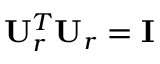<formula> <loc_0><loc_0><loc_500><loc_500>{ U } _ { r } ^ { T } { U } _ { r } = { I }</formula> 